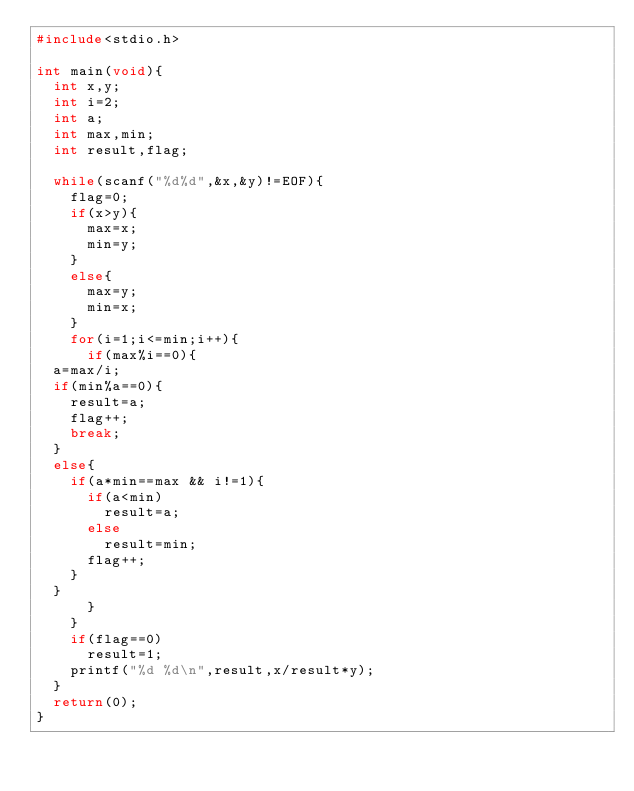<code> <loc_0><loc_0><loc_500><loc_500><_C_>#include<stdio.h>

int main(void){
  int x,y;
  int i=2;
  int a;
  int max,min;
  int result,flag;
  
  while(scanf("%d%d",&x,&y)!=EOF){
    flag=0;
    if(x>y){
      max=x;
      min=y;
    }
    else{
      max=y;
      min=x;
    }
    for(i=1;i<=min;i++){
      if(max%i==0){
	a=max/i;
	if(min%a==0){
	  result=a;
	  flag++;
	  break;
	}
	else{
	  if(a*min==max && i!=1){
	    if(a<min)
	      result=a;
	    else
	      result=min;
	    flag++;
	  }
	}
      }
    }
    if(flag==0)
      result=1;
    printf("%d %d\n",result,x/result*y);
  }
  return(0);
}</code> 